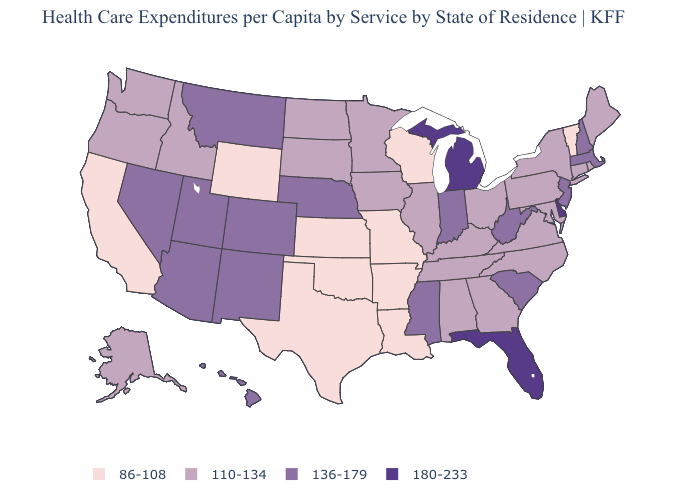Which states have the lowest value in the USA?
Be succinct. Arkansas, California, Kansas, Louisiana, Missouri, Oklahoma, Texas, Vermont, Wisconsin, Wyoming. What is the highest value in the USA?
Keep it brief. 180-233. Name the states that have a value in the range 180-233?
Concise answer only. Delaware, Florida, Michigan. How many symbols are there in the legend?
Write a very short answer. 4. What is the value of Arkansas?
Write a very short answer. 86-108. Name the states that have a value in the range 136-179?
Keep it brief. Arizona, Colorado, Hawaii, Indiana, Massachusetts, Mississippi, Montana, Nebraska, Nevada, New Hampshire, New Jersey, New Mexico, South Carolina, Utah, West Virginia. What is the highest value in states that border Colorado?
Answer briefly. 136-179. Name the states that have a value in the range 86-108?
Answer briefly. Arkansas, California, Kansas, Louisiana, Missouri, Oklahoma, Texas, Vermont, Wisconsin, Wyoming. What is the value of Wyoming?
Quick response, please. 86-108. Name the states that have a value in the range 86-108?
Give a very brief answer. Arkansas, California, Kansas, Louisiana, Missouri, Oklahoma, Texas, Vermont, Wisconsin, Wyoming. What is the value of Iowa?
Give a very brief answer. 110-134. What is the value of Hawaii?
Give a very brief answer. 136-179. What is the value of Missouri?
Be succinct. 86-108. Is the legend a continuous bar?
Answer briefly. No. Name the states that have a value in the range 180-233?
Give a very brief answer. Delaware, Florida, Michigan. 